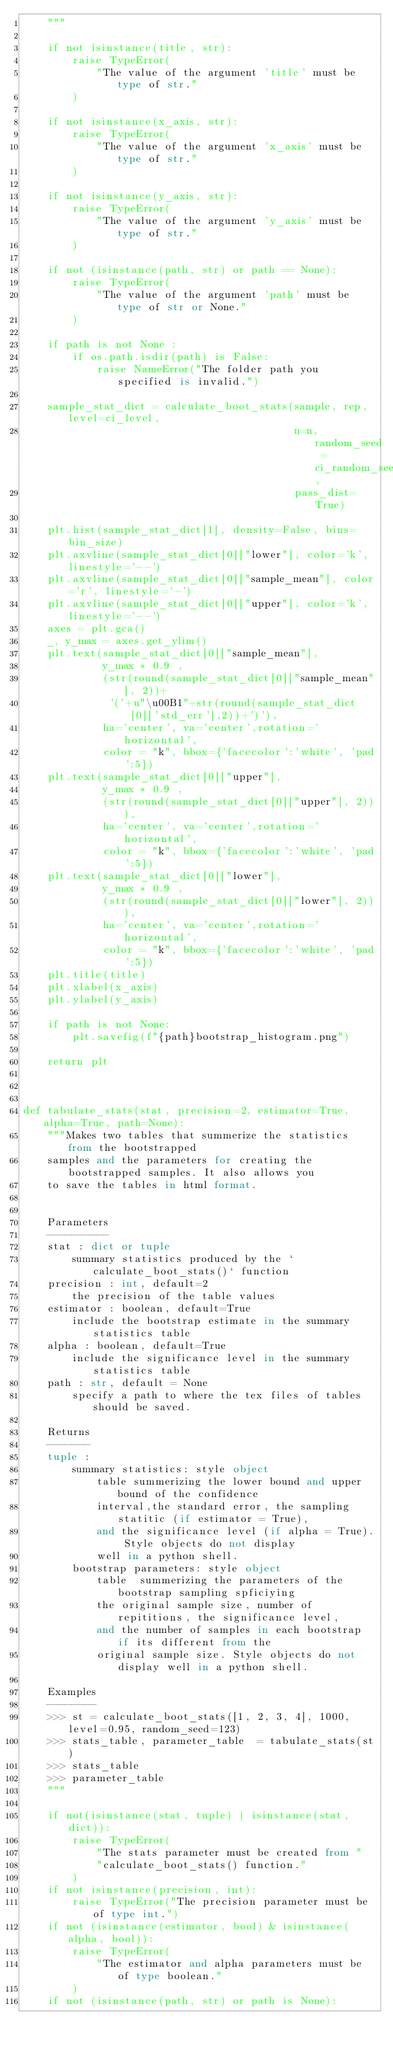Convert code to text. <code><loc_0><loc_0><loc_500><loc_500><_Python_>    """

    if not isinstance(title, str):
        raise TypeError(
            "The value of the argument 'title' must be type of str."
        )
        
    if not isinstance(x_axis, str):
        raise TypeError(
            "The value of the argument 'x_axis' must be type of str."
        )
        
    if not isinstance(y_axis, str):
        raise TypeError(
            "The value of the argument 'y_axis' must be type of str."
        )

    if not (isinstance(path, str) or path == None):
        raise TypeError(
            "The value of the argument 'path' must be type of str or None."
        )
        
    if path is not None :
        if os.path.isdir(path) is False:
            raise NameError("The folder path you specified is invalid.")

    sample_stat_dict = calculate_boot_stats(sample, rep, level=ci_level, 
                                            n=n, random_seed = ci_random_seed,
                                            pass_dist=True)
        
    plt.hist(sample_stat_dict[1], density=False, bins=bin_size)
    plt.axvline(sample_stat_dict[0]["lower"], color='k', linestyle='--')
    plt.axvline(sample_stat_dict[0]["sample_mean"], color='r', linestyle='-')
    plt.axvline(sample_stat_dict[0]["upper"], color='k', linestyle='--')
    axes = plt.gca()
    _, y_max = axes.get_ylim()
    plt.text(sample_stat_dict[0]["sample_mean"], 
             y_max * 0.9 , 
             (str(round(sample_stat_dict[0]["sample_mean"], 2))+
              '('+u"\u00B1"+str(round(sample_stat_dict[0]['std_err'],2))+')'), 
             ha='center', va='center',rotation='horizontal', 
             color = "k", bbox={'facecolor':'white', 'pad':5})
    plt.text(sample_stat_dict[0]["upper"], 
             y_max * 0.9 , 
             (str(round(sample_stat_dict[0]["upper"], 2))), 
             ha='center', va='center',rotation='horizontal', 
             color = "k", bbox={'facecolor':'white', 'pad':5})
    plt.text(sample_stat_dict[0]["lower"], 
             y_max * 0.9 , 
             (str(round(sample_stat_dict[0]["lower"], 2))), 
             ha='center', va='center',rotation='horizontal', 
             color = "k", bbox={'facecolor':'white', 'pad':5})
    plt.title(title)
    plt.xlabel(x_axis)
    plt.ylabel(y_axis)

    if path is not None:
        plt.savefig(f"{path}bootstrap_histogram.png")

    return plt
    


def tabulate_stats(stat, precision=2, estimator=True, alpha=True, path=None):
    """Makes two tables that summerize the statistics from the bootstrapped 
    samples and the parameters for creating the bootstrapped samples. It also allows you
    to save the tables in html format. 


    Parameters
    ----------
    stat : dict or tuple
        summary statistics produced by the `calculate_boot_stats()` function 
    precision : int, default=2
        the precision of the table values
    estimator : boolean, default=True
        include the bootstrap estimate in the summary statistics table
    alpha : boolean, default=True
        include the significance level in the summary statistics table
    path : str, default = None
        specify a path to where the tex files of tables should be saved.

    Returns
    -------
    tuple :
        summary statistics: style object
            table summerizing the lower bound and upper bound of the confidence
            interval,the standard error, the sampling statitic (if estimator = True),
            and the significance level (if alpha = True). Style objects do not display
            well in a python shell.
        bootstrap parameters: style object
            table  summerizing the parameters of the bootstrap sampling spficiying
            the original sample size, number of repititions, the significance level,
            and the number of samples in each bootstrap if its different from the
            original sample size. Style objects do not display well in a python shell.
        
    Examples
    --------
    >>> st = calculate_boot_stats([1, 2, 3, 4], 1000, level=0.95, random_seed=123)
    >>> stats_table, parameter_table  = tabulate_stats(st)
    >>> stats_table
    >>> parameter_table
    """

    if not(isinstance(stat, tuple) | isinstance(stat, dict)):
        raise TypeError(
            "The stats parameter must be created from "
            "calculate_boot_stats() function."
        )
    if not isinstance(precision, int):
        raise TypeError("The precision parameter must be of type int.")
    if not (isinstance(estimator, bool) & isinstance(alpha, bool)):
        raise TypeError(
            "The estimator and alpha parameters must be of type boolean."
        )
    if not (isinstance(path, str) or path is None):</code> 